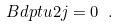<formula> <loc_0><loc_0><loc_500><loc_500>\ B d p t { u } { 2 j } = 0 \ .</formula> 